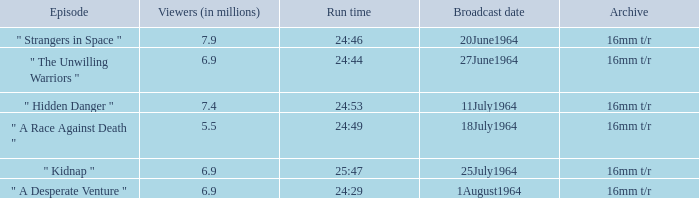What is run time when there were 7.4 million viewers? 24:53. 